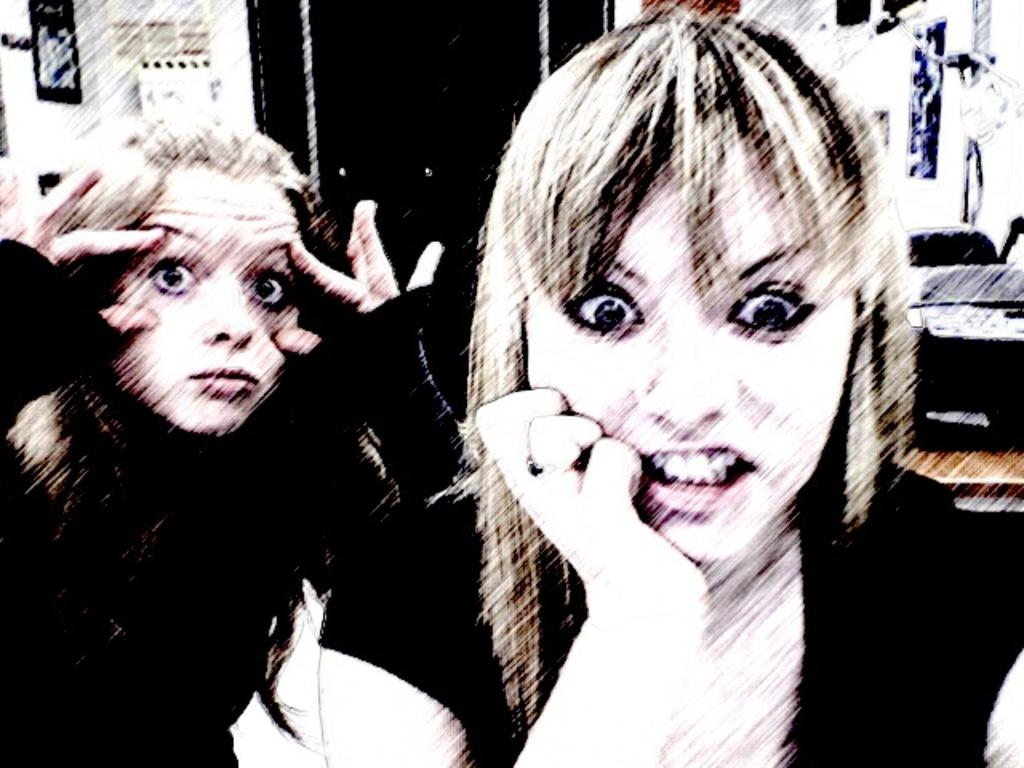How many people are present in the image? There are two women in the image. What kind of expression can be seen on the faces of the women? The women are giving some expression, but the specific expression cannot be determined from the facts provided. What type of lock is being adjusted by the women in the image? There is no lock present in the image, and therefore no adjustment can be observed. 